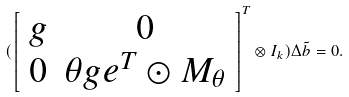<formula> <loc_0><loc_0><loc_500><loc_500>( \left [ \begin{array} { c c } g & 0 \\ 0 & \theta g e ^ { T } \odot M _ { \theta } \end{array} \right ] ^ { T } \otimes I _ { k } ) \Delta \tilde { b } = 0 .</formula> 